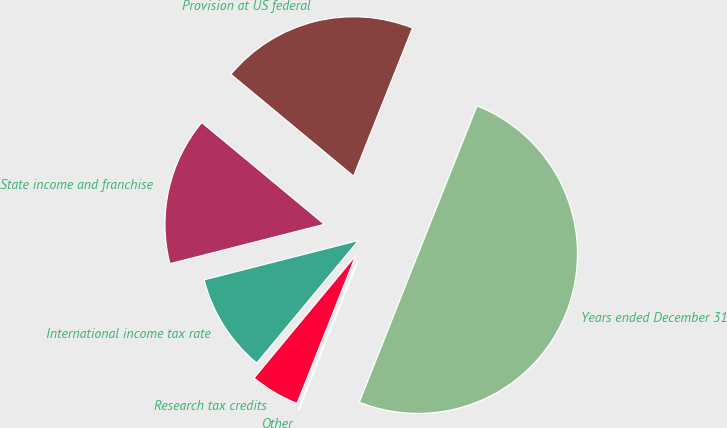Convert chart to OTSL. <chart><loc_0><loc_0><loc_500><loc_500><pie_chart><fcel>Years ended December 31<fcel>Provision at US federal<fcel>State income and franchise<fcel>International income tax rate<fcel>Research tax credits<fcel>Other<nl><fcel>49.98%<fcel>20.0%<fcel>15.0%<fcel>10.0%<fcel>5.01%<fcel>0.01%<nl></chart> 